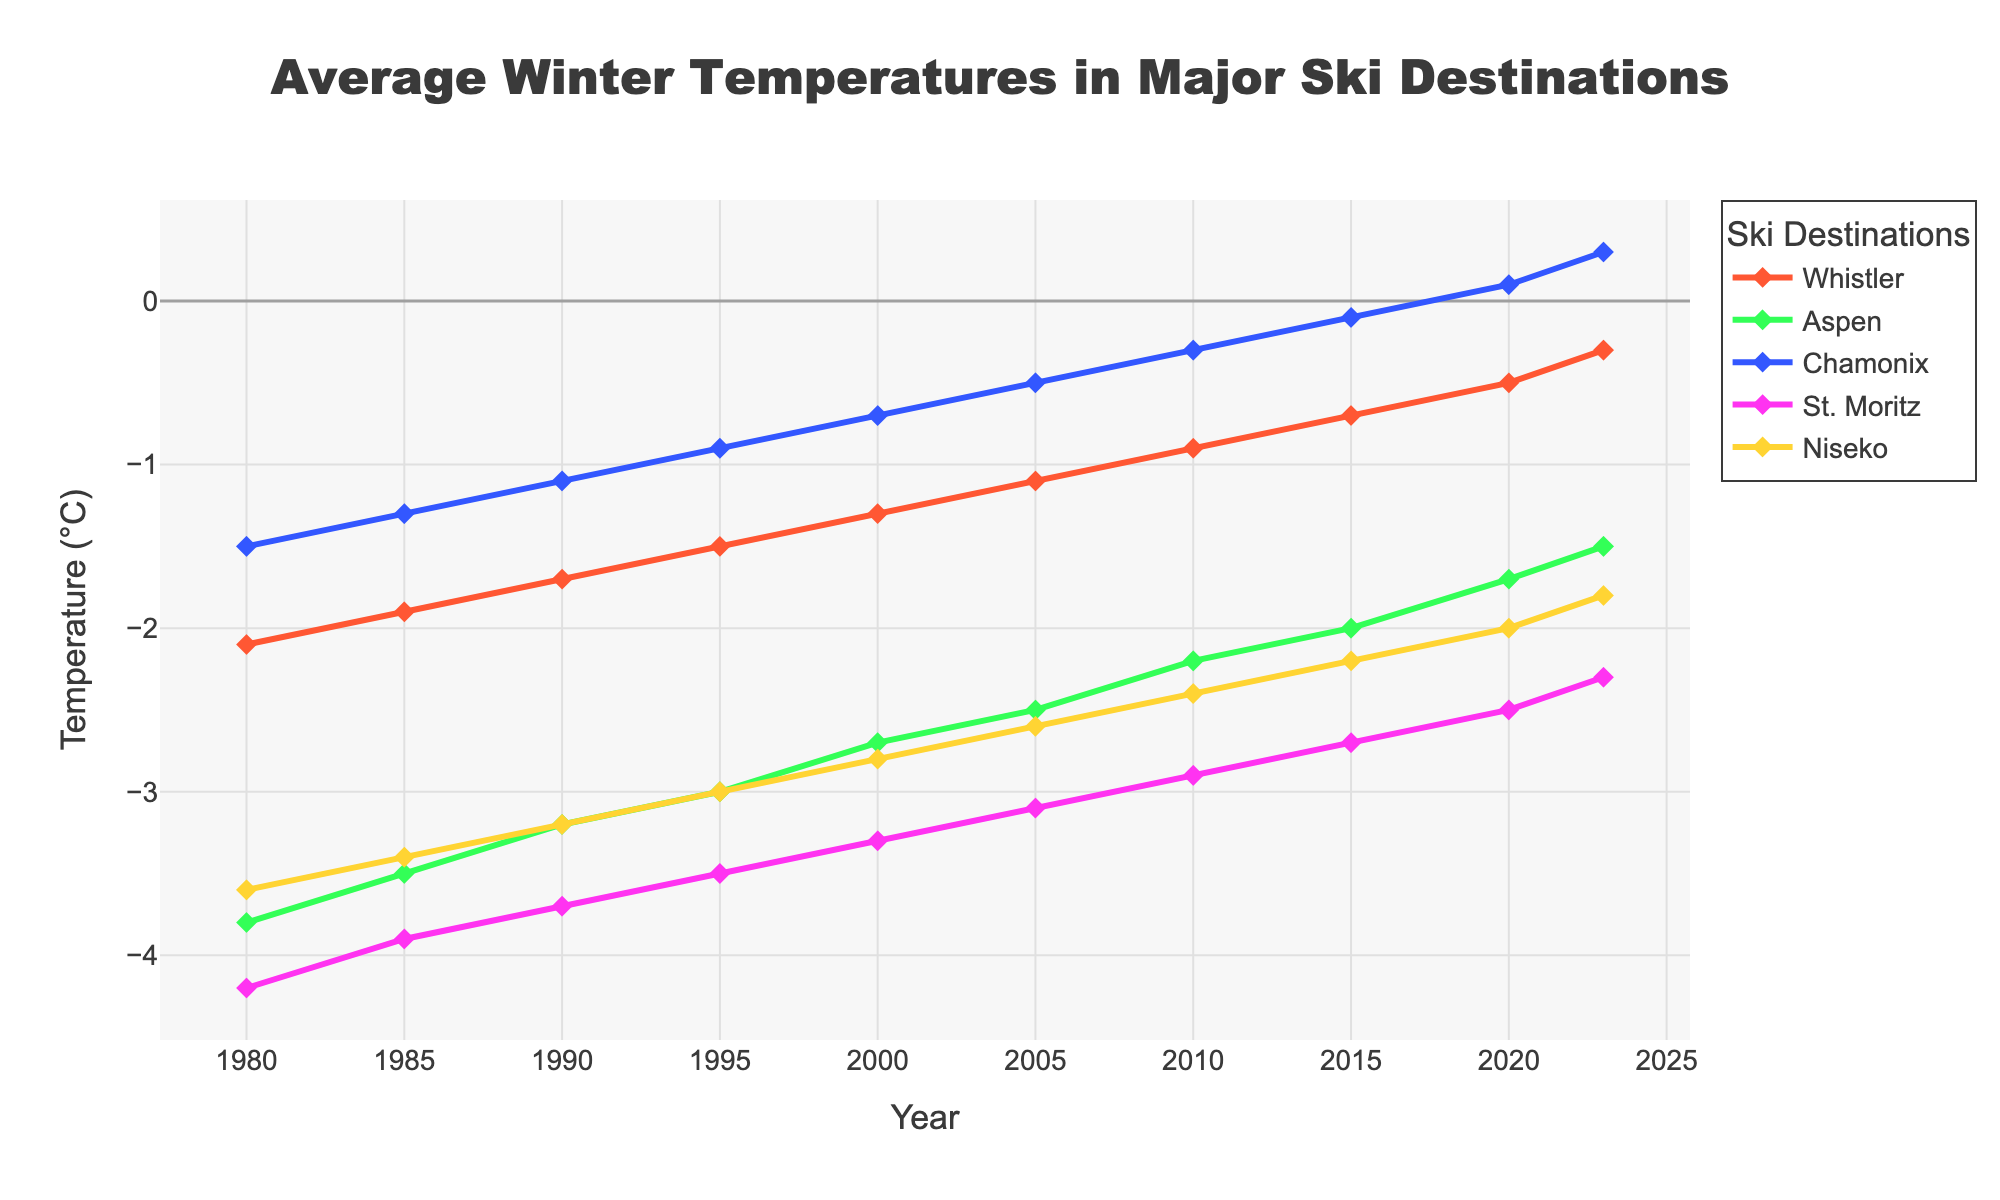what is the trend of average temperatures in Whistler from 1980 to 2023? Observe the line associated with Whistler from 1980 to 2023, which generally shows an upward (increasing temperature) trend over the years
Answer: increasing which ski destination had the coldest average temperature in 1980? Look at the points representing 1980. St. Moritz has the lowest point among all destinations in that year
Answer: St. Moritz how does the temperature trend in Niseko compare with that in Chamonix? Analyze the two lines representing Niseko and Chamonix. Both lines show an increasing trend but start from different baselines
Answer: both increasing during which period did Aspen see the most significant temperature rise? Observe the slope of Aspen's line. The steepest increase appears to be from 2010 to 2023
Answer: 2010-2023 On average, which decade saw the fastest temperature increase in Whistler? Calculate the difference in Whistler's temperatures for each decade and compare. The fastest increase is observed from 2010 to 2020
Answer: 2010-2020 How many degrees has St. Moritz warmed from 1980 to 2023? Subtract the average temperature of St. Moritz in 1980 from that in 2023. (-2.3) - (-4.2) = 1.9 degrees
Answer: 1.9 degrees Were there any years where Chamonix had above-zero average temperatures? Examine the points for Chamonix. Yes, the line crosses above zero from 2015 onwards
Answer: Yes Compare the temperatures of Aspen and Whistler in 2020. Refer to the points for 2020 for both lines. Aspen: -1.7, Whistler: -0.5
Answer: Aspen: -1.7, Whistler: -0.5 Which destination has experienced the least amount of warming from 1980 to 2023? Calculate the temperature change for each destination and compare. Niseko's change is the smallest from -3.6 to -1.8: 1.8 degrees
Answer: Niseko 